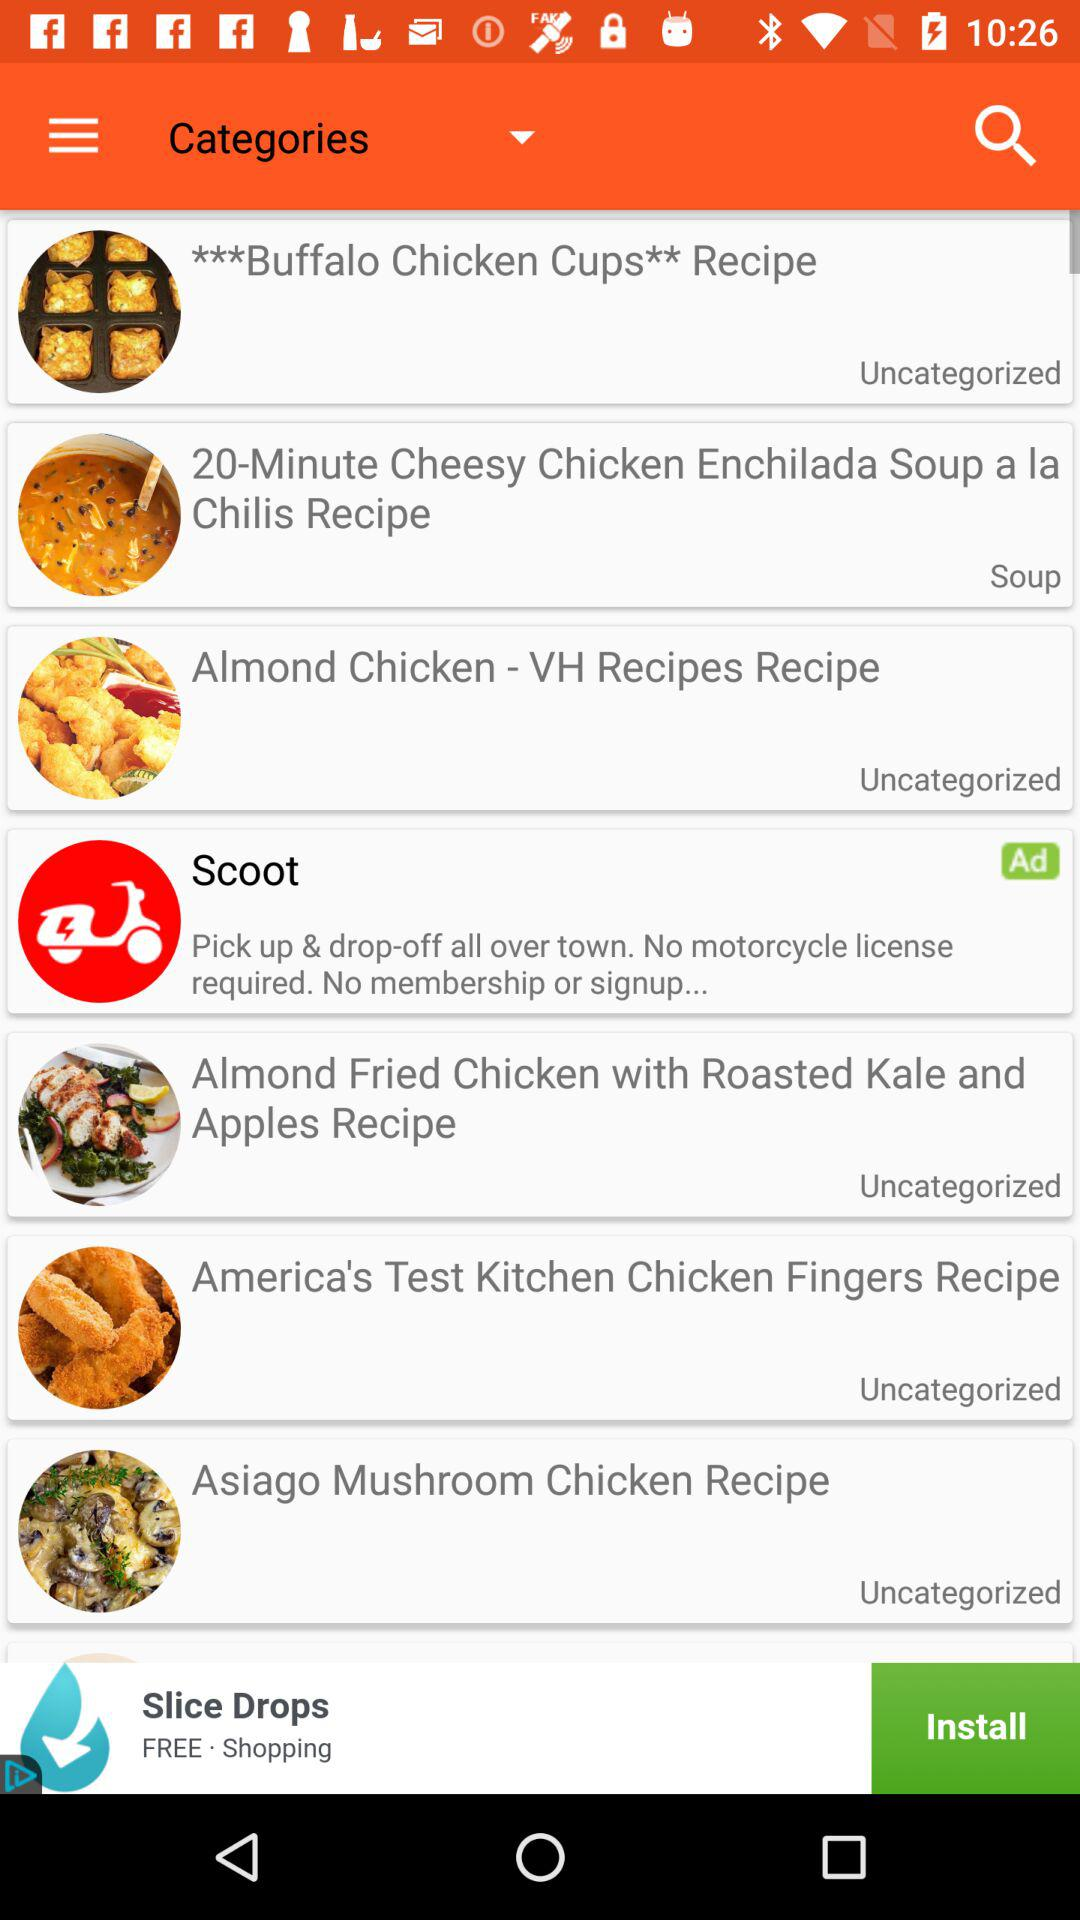What is the time duration of the cheesy chicken recipe? The time duration of the cheesy chicken recipe is 20 minutes. 